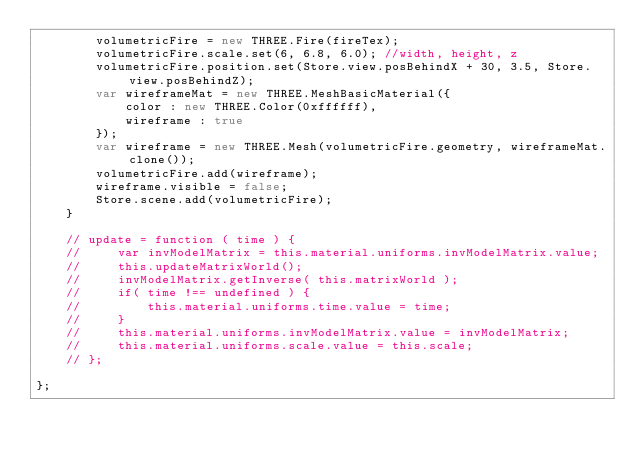<code> <loc_0><loc_0><loc_500><loc_500><_JavaScript_>        volumetricFire = new THREE.Fire(fireTex);
        volumetricFire.scale.set(6, 6.8, 6.0); //width, height, z
        volumetricFire.position.set(Store.view.posBehindX + 30, 3.5, Store.view.posBehindZ);
        var wireframeMat = new THREE.MeshBasicMaterial({
            color : new THREE.Color(0xffffff),
            wireframe : true
        });
        var wireframe = new THREE.Mesh(volumetricFire.geometry, wireframeMat.clone());
        volumetricFire.add(wireframe);
        wireframe.visible = false;
        Store.scene.add(volumetricFire);
    }

    // update = function ( time ) {
    //     var invModelMatrix = this.material.uniforms.invModelMatrix.value;
    //     this.updateMatrixWorld();
    //     invModelMatrix.getInverse( this.matrixWorld );
    //     if( time !== undefined ) {
    //         this.material.uniforms.time.value = time;
    //     }
    //     this.material.uniforms.invModelMatrix.value = invModelMatrix;
    //     this.material.uniforms.scale.value = this.scale;
    // };

};</code> 